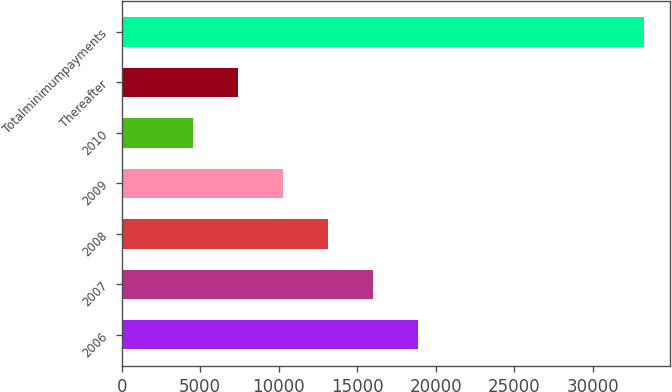<chart> <loc_0><loc_0><loc_500><loc_500><bar_chart><fcel>2006<fcel>2007<fcel>2008<fcel>2009<fcel>2010<fcel>Thereafter<fcel>Totalminimumpayments<nl><fcel>18907.5<fcel>16030.8<fcel>13154.1<fcel>10277.4<fcel>4524<fcel>7400.7<fcel>33291<nl></chart> 